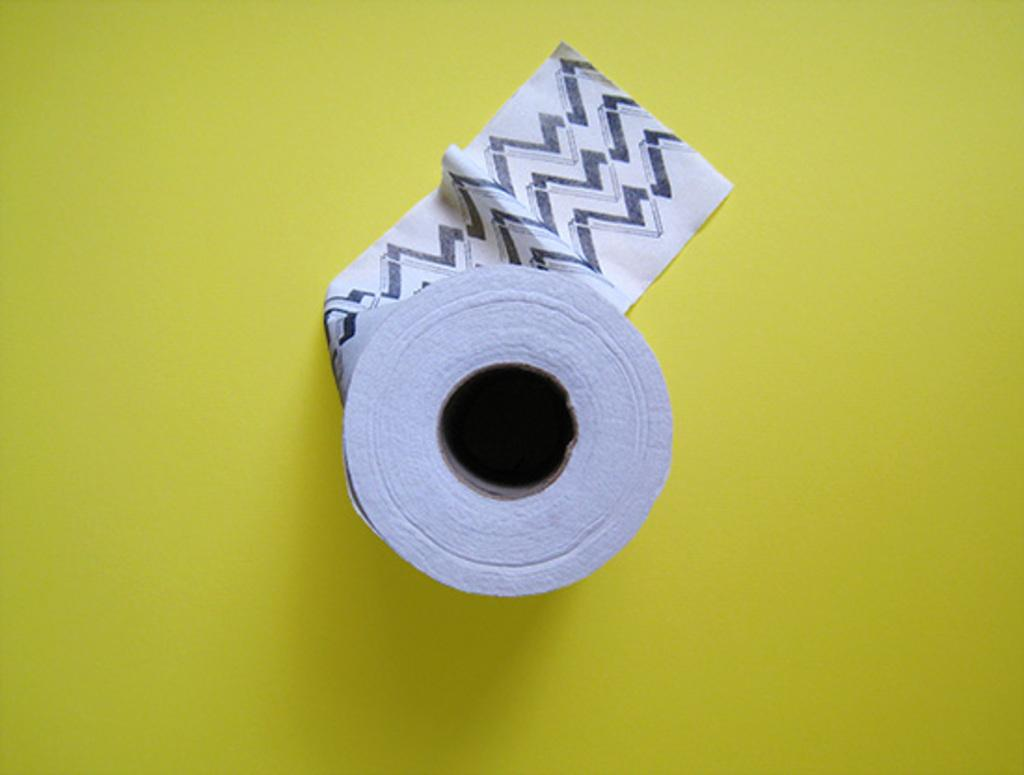What object is in the center of the image? The tissue paper is in the center of the image. Where is the tissue paper located? The tissue paper is placed on a table. What type of shoes are visible in the image? There are no shoes present in the image; it only features a tissue paper on a table. What time of day is depicted in the image? The image does not provide any information about the time of day. 